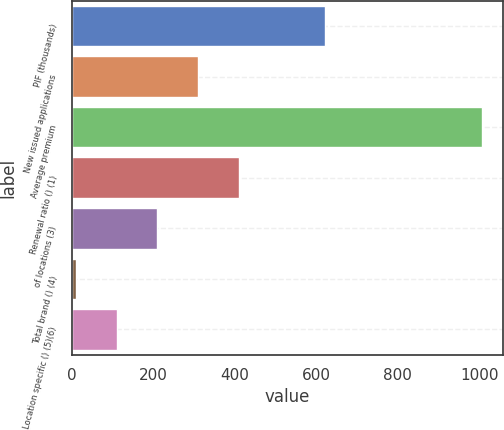<chart> <loc_0><loc_0><loc_500><loc_500><bar_chart><fcel>PIF (thousands)<fcel>New issued applications<fcel>Average premium<fcel>Renewal ratio () (1)<fcel>of locations (3)<fcel>Total brand () (4)<fcel>Location specific () (5)(6)<nl><fcel>622<fcel>309.75<fcel>1008<fcel>409.5<fcel>210<fcel>10.5<fcel>110.25<nl></chart> 